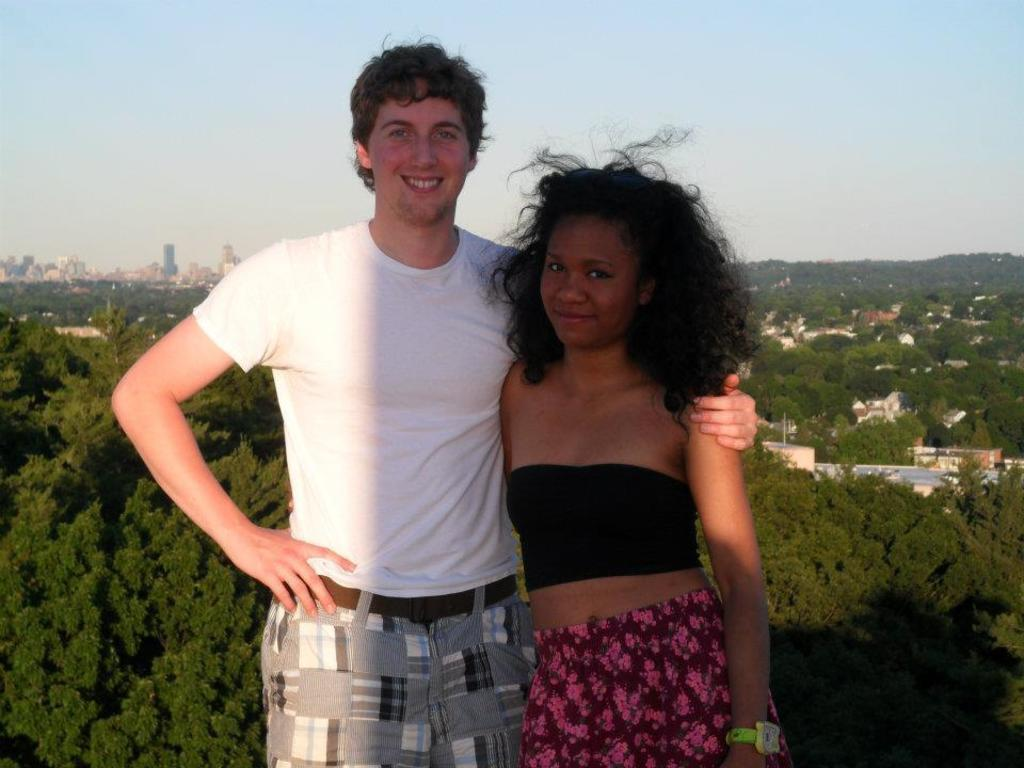Who is present in the image? There is a man and a woman in the image. What are the man and woman doing in the image? Both the man and woman are posing for a photo. What can be seen in the background of the image? There are many trees and houses visible in the background of the image. What type of humor can be seen in the man's sock in the image? There is no mention of a sock in the image, and therefore no humor can be attributed to it. 